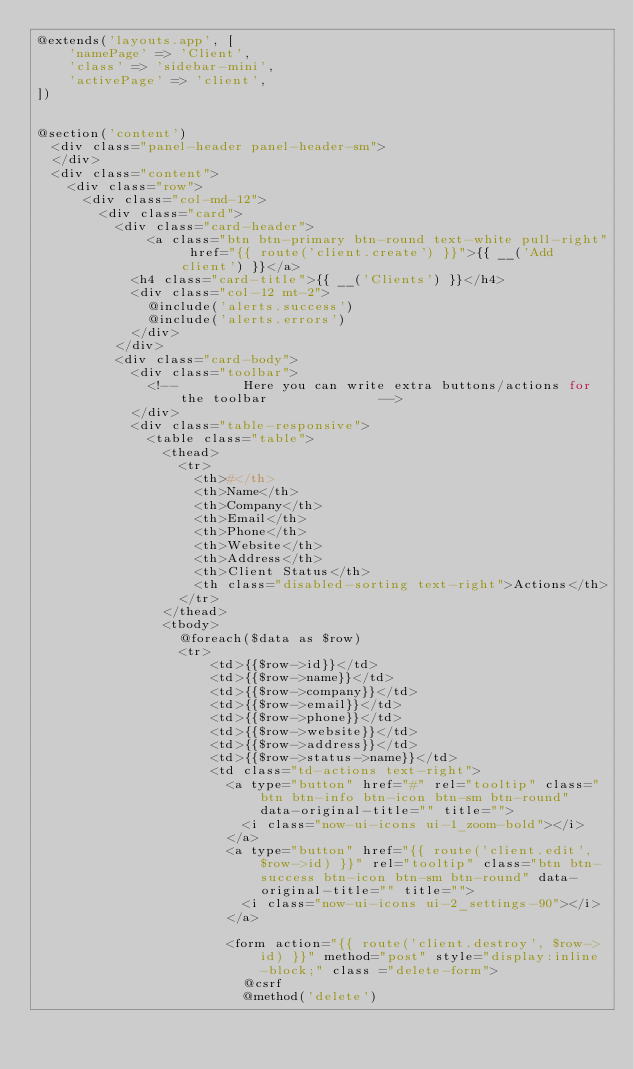<code> <loc_0><loc_0><loc_500><loc_500><_PHP_>@extends('layouts.app', [
    'namePage' => 'Client',
    'class' => 'sidebar-mini',
    'activePage' => 'client',
])


@section('content')
  <div class="panel-header panel-header-sm">
  </div>
  <div class="content">
    <div class="row">
      <div class="col-md-12">
        <div class="card">
          <div class="card-header">
              <a class="btn btn-primary btn-round text-white pull-right" href="{{ route('client.create') }}">{{ __('Add client') }}</a>
            <h4 class="card-title">{{ __('Clients') }}</h4>
            <div class="col-12 mt-2">
              @include('alerts.success')
              @include('alerts.errors')
            </div>
          </div>
          <div class="card-body">
            <div class="toolbar">
              <!--        Here you can write extra buttons/actions for the toolbar              -->
            </div>
            <div class="table-responsive">
              <table class="table">
                <thead>
                  <tr>
                    <th>#</th>
                    <th>Name</th>
                    <th>Company</th>
                    <th>Email</th>
                    <th>Phone</th>
                    <th>Website</th>
                    <th>Address</th>
                    <th>Client Status</th>
                    <th class="disabled-sorting text-right">Actions</th>
                  </tr>
                </thead>
                <tbody>
                  @foreach($data as $row)
                  <tr>
                      <td>{{$row->id}}</td>
                      <td>{{$row->name}}</td>
                      <td>{{$row->company}}</td>
                      <td>{{$row->email}}</td>
                      <td>{{$row->phone}}</td>
                      <td>{{$row->website}}</td>
                      <td>{{$row->address}}</td>
                      <td>{{$row->status->name}}</td>
                      <td class="td-actions text-right">
                        <a type="button" href="#" rel="tooltip" class="btn btn-info btn-icon btn-sm btn-round" data-original-title="" title="">
                          <i class="now-ui-icons ui-1_zoom-bold"></i>
                        </a>
                        <a type="button" href="{{ route('client.edit',$row->id) }}" rel="tooltip" class="btn btn-success btn-icon btn-sm btn-round" data-original-title="" title="">
                          <i class="now-ui-icons ui-2_settings-90"></i>
                        </a>

                        <form action="{{ route('client.destroy', $row->id) }}" method="post" style="display:inline-block;" class ="delete-form">
                          @csrf
                          @method('delete')</code> 